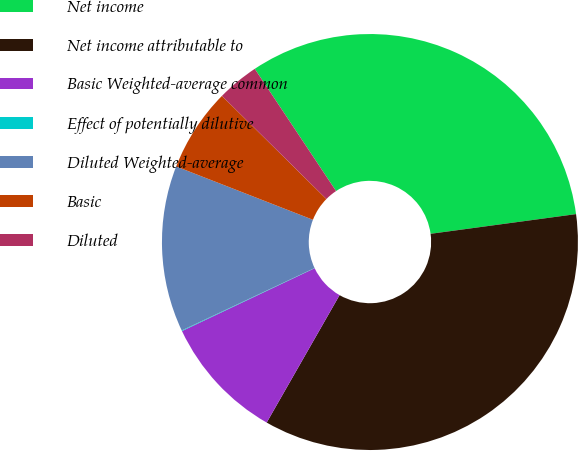<chart> <loc_0><loc_0><loc_500><loc_500><pie_chart><fcel>Net income<fcel>Net income attributable to<fcel>Basic Weighted-average common<fcel>Effect of potentially dilutive<fcel>Diluted Weighted-average<fcel>Basic<fcel>Diluted<nl><fcel>32.2%<fcel>35.41%<fcel>9.69%<fcel>0.05%<fcel>12.91%<fcel>6.48%<fcel>3.26%<nl></chart> 